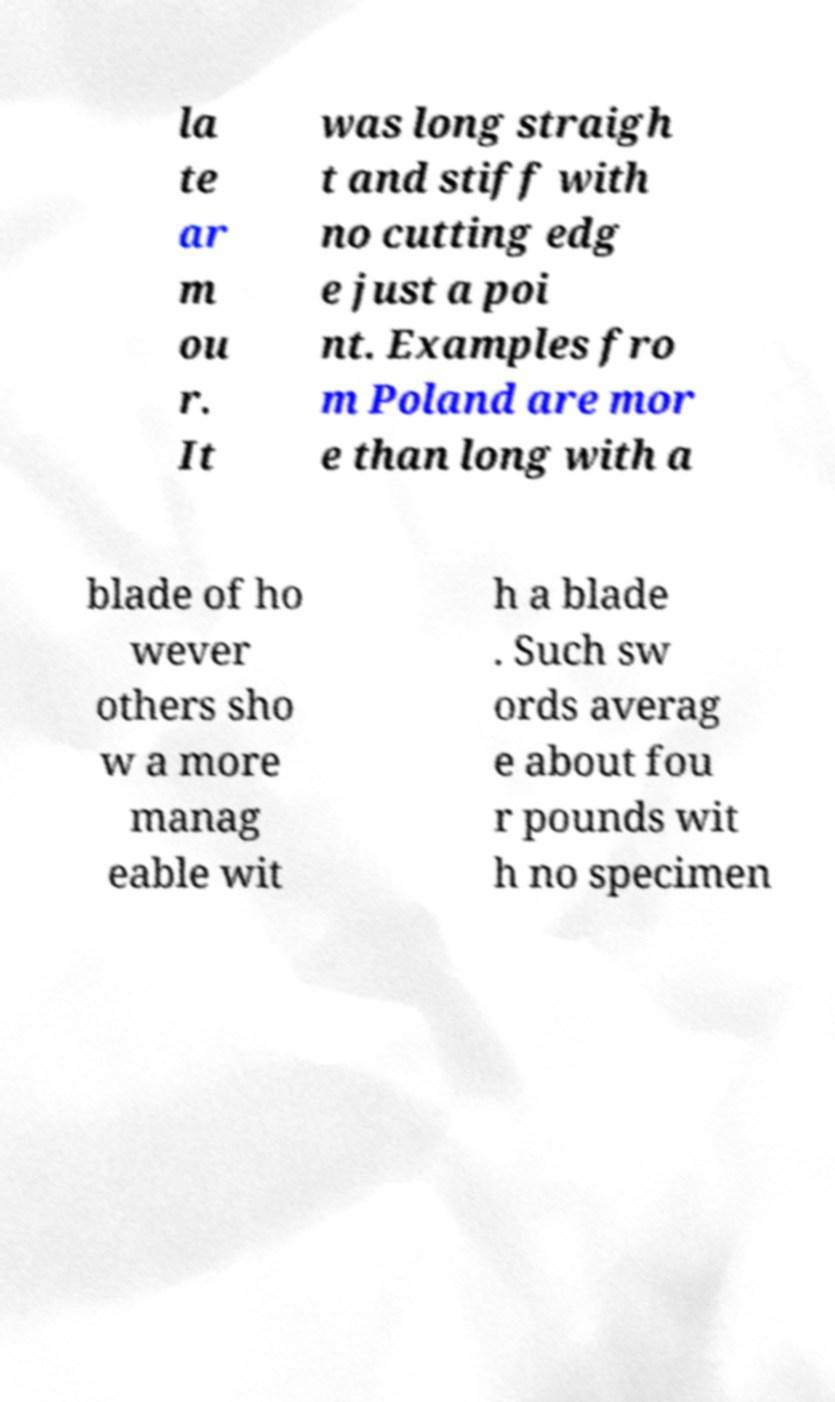Could you assist in decoding the text presented in this image and type it out clearly? la te ar m ou r. It was long straigh t and stiff with no cutting edg e just a poi nt. Examples fro m Poland are mor e than long with a blade of ho wever others sho w a more manag eable wit h a blade . Such sw ords averag e about fou r pounds wit h no specimen 